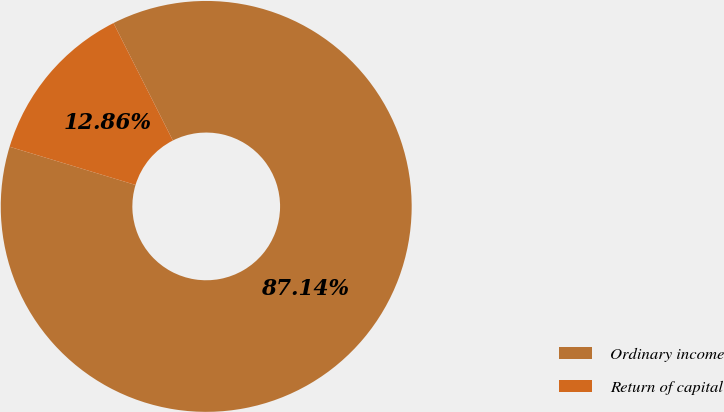<chart> <loc_0><loc_0><loc_500><loc_500><pie_chart><fcel>Ordinary income<fcel>Return of capital<nl><fcel>87.14%<fcel>12.86%<nl></chart> 